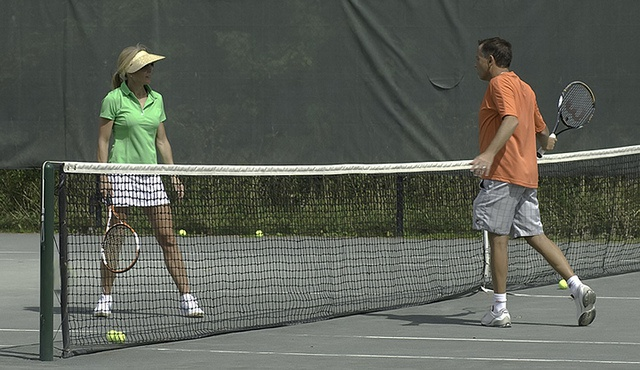Describe the objects in this image and their specific colors. I can see people in black, gray, and darkgray tones, people in black, gray, darkgray, and white tones, tennis racket in black, gray, and darkgray tones, tennis racket in black, gray, darkgray, and purple tones, and sports ball in black, khaki, olive, and darkgreen tones in this image. 